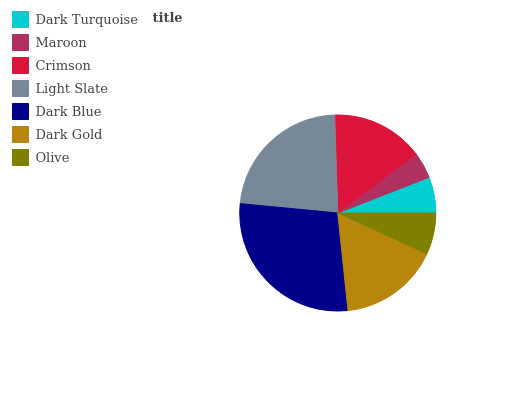Is Maroon the minimum?
Answer yes or no. Yes. Is Dark Blue the maximum?
Answer yes or no. Yes. Is Crimson the minimum?
Answer yes or no. No. Is Crimson the maximum?
Answer yes or no. No. Is Crimson greater than Maroon?
Answer yes or no. Yes. Is Maroon less than Crimson?
Answer yes or no. Yes. Is Maroon greater than Crimson?
Answer yes or no. No. Is Crimson less than Maroon?
Answer yes or no. No. Is Crimson the high median?
Answer yes or no. Yes. Is Crimson the low median?
Answer yes or no. Yes. Is Dark Blue the high median?
Answer yes or no. No. Is Dark Blue the low median?
Answer yes or no. No. 